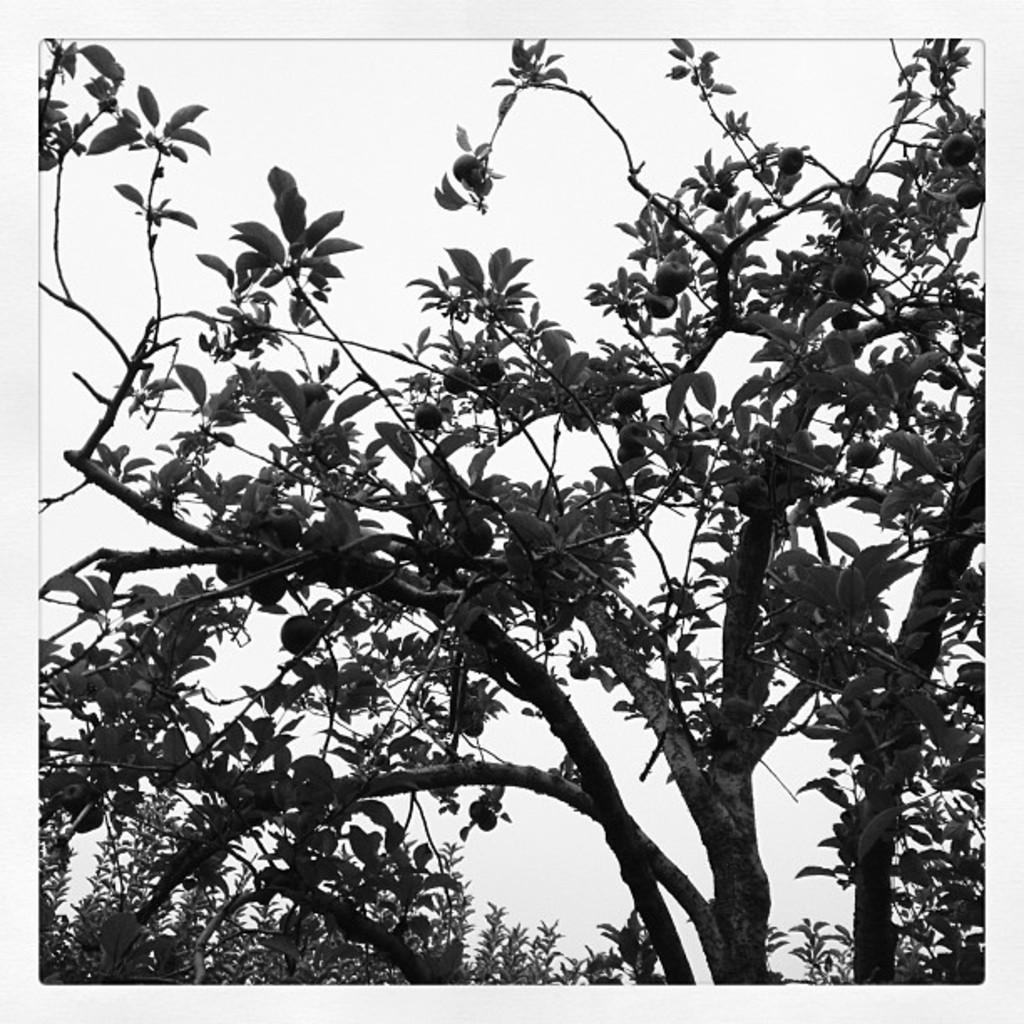In one or two sentences, can you explain what this image depicts? This is a black and white picture. In the picture there are trees. In the center of the picture there are fruits to the tree. The picture has white border. 